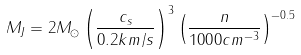<formula> <loc_0><loc_0><loc_500><loc_500>M _ { J } = 2 M _ { \odot } \left ( \frac { c _ { s } } { 0 . 2 k m / s } \right ) ^ { 3 } \left ( \frac { n } { 1 0 0 0 c m ^ { - 3 } } \right ) ^ { - 0 . 5 }</formula> 